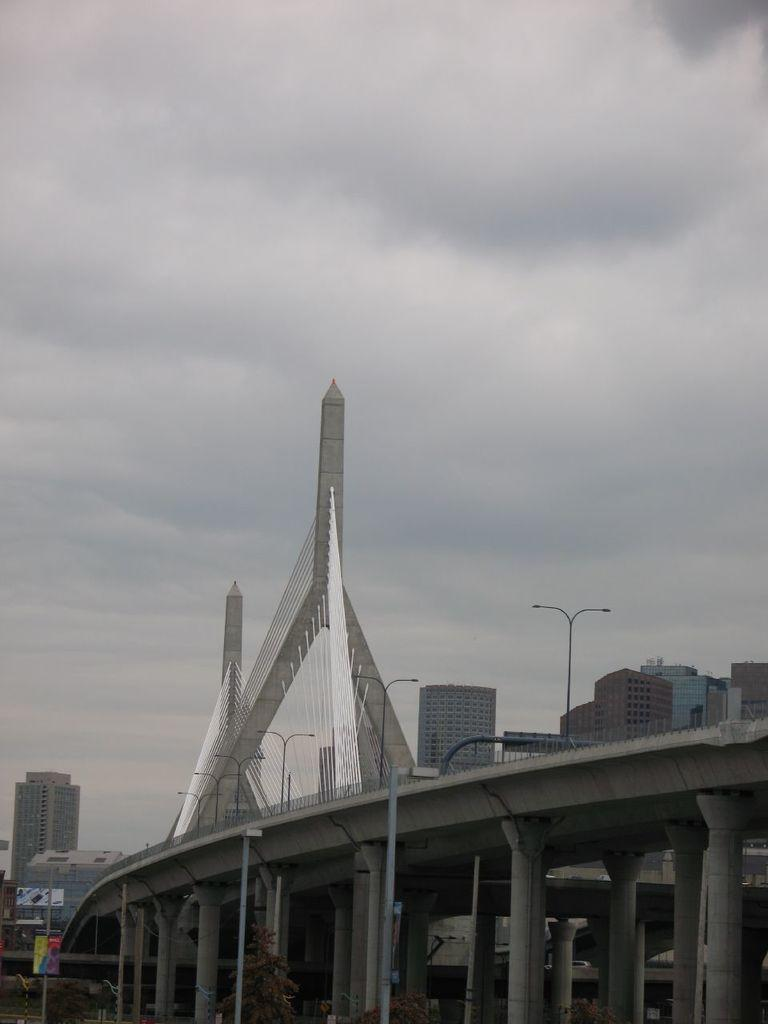What is the main structure in the center of the image? There is a bridge in the center of the image. What else can be seen in the image besides the bridge? There are poles in the image. What can be seen in the background of the image? There are buildings and the sky visible in the background of the image. What type of vegetation is at the bottom of the image? There are trees at the bottom of the image. How many feet are visible in the image? There are no feet visible in the image. Are there any slaves depicted in the image? There is no mention of slaves or any related context in the image. 